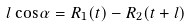Convert formula to latex. <formula><loc_0><loc_0><loc_500><loc_500>l \cos \alpha = R _ { 1 } ( t ) - R _ { 2 } ( t + l )</formula> 